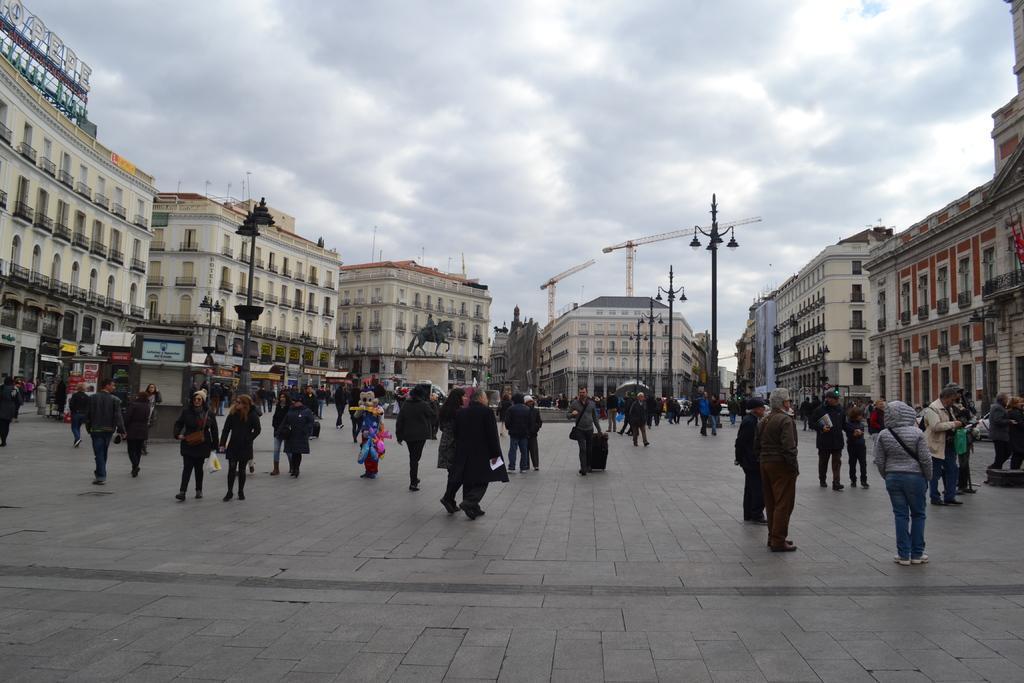Please provide a concise description of this image. In this picture we can see people on the ground and in the background we can see a statue,buildings,poles,sky. 